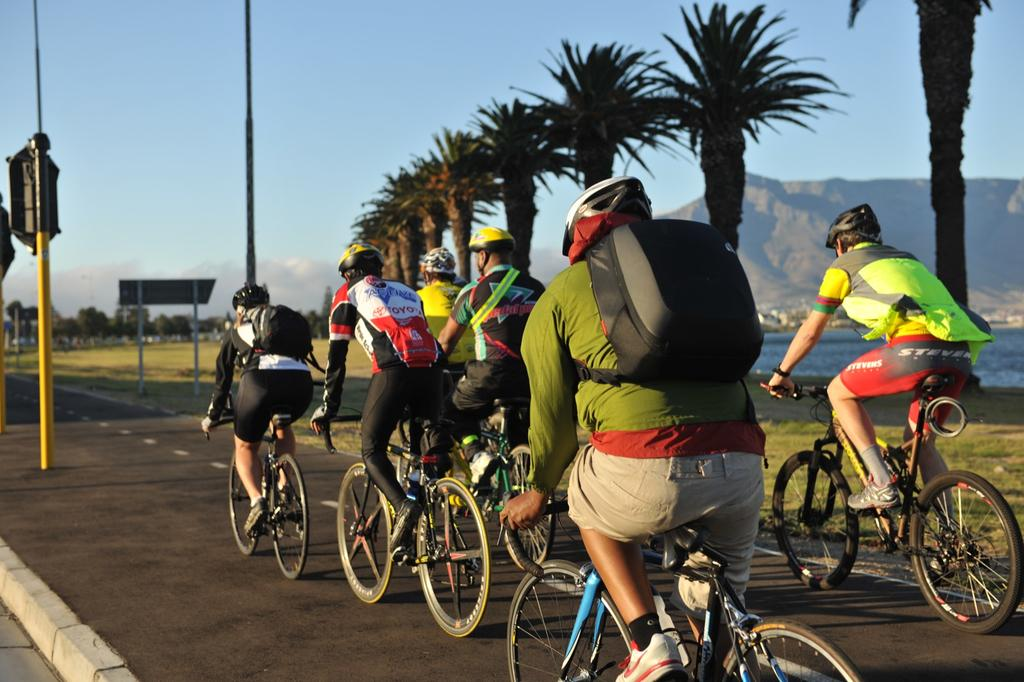What are the people in the image doing? The people in the image are riding bicycles. What type of natural environment can be seen in the image? There are trees and water visible in the image. What geographical feature is present in the image? There is a hill in the image. What is the price of the chess set in the image? There is no chess set present in the image, so it is not possible to determine its price. 